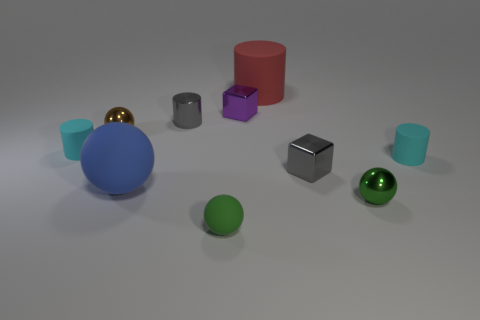How many matte cylinders are the same size as the blue matte sphere?
Provide a succinct answer. 1. How many brown objects are large balls or tiny metal things?
Ensure brevity in your answer.  1. Are there the same number of tiny gray shiny cylinders that are behind the gray metallic cylinder and small purple cylinders?
Ensure brevity in your answer.  Yes. How big is the cylinder that is behind the small shiny cylinder?
Your answer should be very brief. Large. How many yellow metal things have the same shape as the brown thing?
Your answer should be very brief. 0. What is the thing that is behind the gray cube and right of the big red cylinder made of?
Ensure brevity in your answer.  Rubber. Do the small purple thing and the large red cylinder have the same material?
Ensure brevity in your answer.  No. What number of small metallic spheres are there?
Keep it short and to the point. 2. There is a big rubber cylinder behind the small rubber thing on the right side of the tiny green matte ball that is in front of the large red cylinder; what is its color?
Keep it short and to the point. Red. How many balls are in front of the tiny gray metal block and to the left of the tiny purple cube?
Provide a short and direct response. 2. 